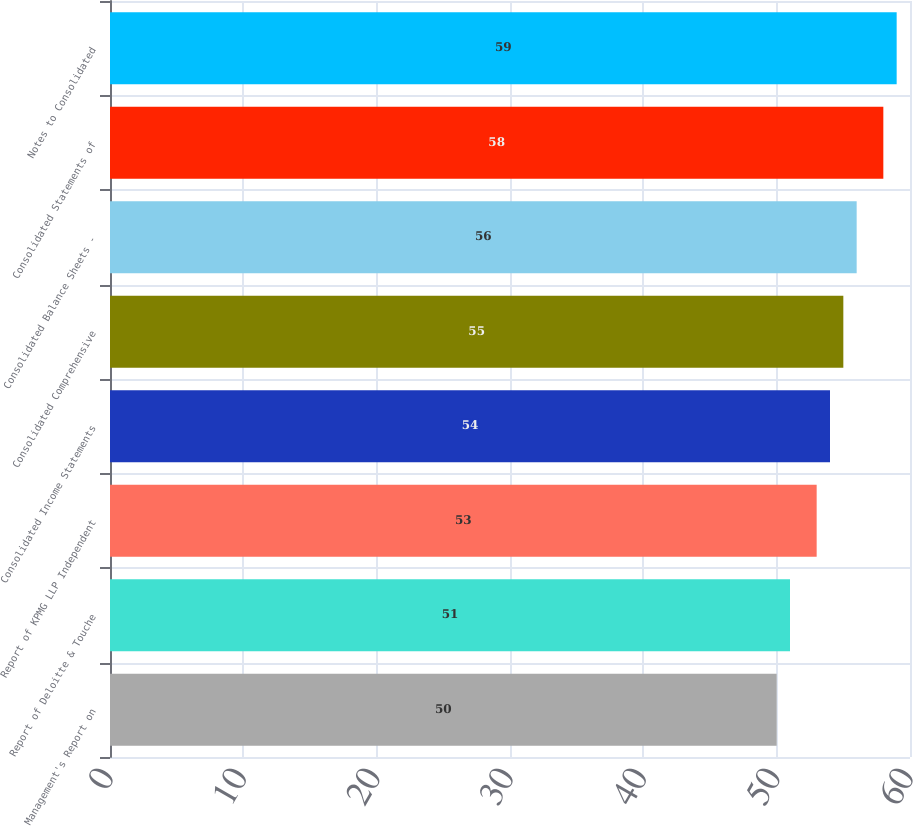Convert chart. <chart><loc_0><loc_0><loc_500><loc_500><bar_chart><fcel>Management's Report on<fcel>Report of Deloitte & Touche<fcel>Report of KPMG LLP Independent<fcel>Consolidated Income Statements<fcel>Consolidated Comprehensive<fcel>Consolidated Balance Sheets -<fcel>Consolidated Statements of<fcel>Notes to Consolidated<nl><fcel>50<fcel>51<fcel>53<fcel>54<fcel>55<fcel>56<fcel>58<fcel>59<nl></chart> 